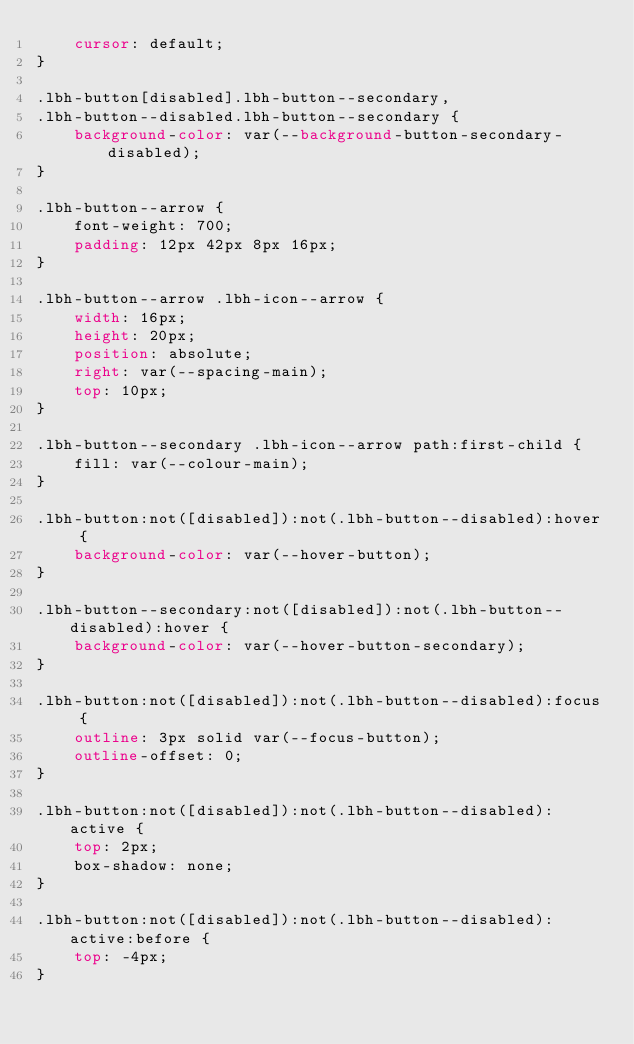<code> <loc_0><loc_0><loc_500><loc_500><_CSS_>    cursor: default;
}

.lbh-button[disabled].lbh-button--secondary,
.lbh-button--disabled.lbh-button--secondary {
    background-color: var(--background-button-secondary-disabled);
}

.lbh-button--arrow {
    font-weight: 700;
    padding: 12px 42px 8px 16px;
}

.lbh-button--arrow .lbh-icon--arrow {
    width: 16px;
    height: 20px;
    position: absolute;
    right: var(--spacing-main);
    top: 10px;
}

.lbh-button--secondary .lbh-icon--arrow path:first-child {
    fill: var(--colour-main);
}

.lbh-button:not([disabled]):not(.lbh-button--disabled):hover {
    background-color: var(--hover-button);
}

.lbh-button--secondary:not([disabled]):not(.lbh-button--disabled):hover {
    background-color: var(--hover-button-secondary);
}

.lbh-button:not([disabled]):not(.lbh-button--disabled):focus {
    outline: 3px solid var(--focus-button);
    outline-offset: 0;
}

.lbh-button:not([disabled]):not(.lbh-button--disabled):active {
    top: 2px;
    box-shadow: none;
}

.lbh-button:not([disabled]):not(.lbh-button--disabled):active:before {
    top: -4px;
}</code> 